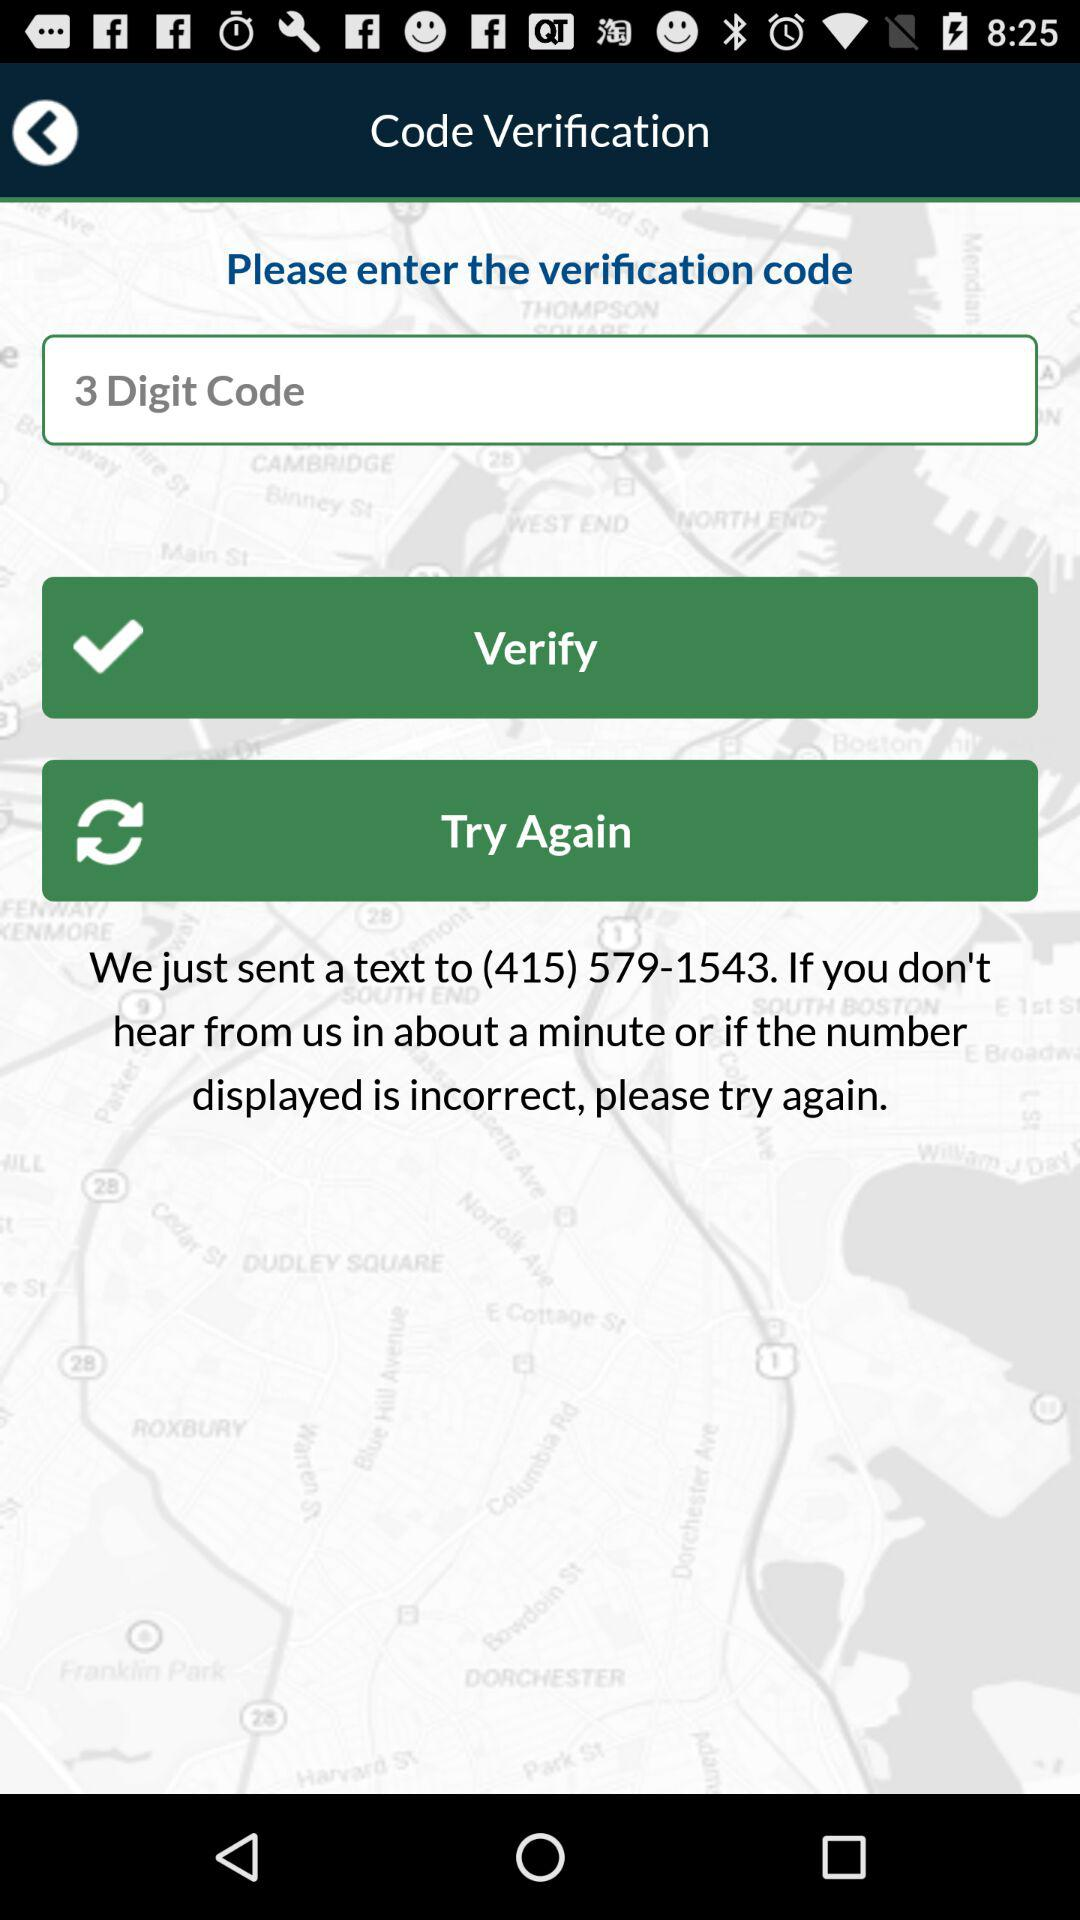How many digits are there in the verification code?
Answer the question using a single word or phrase. 3 